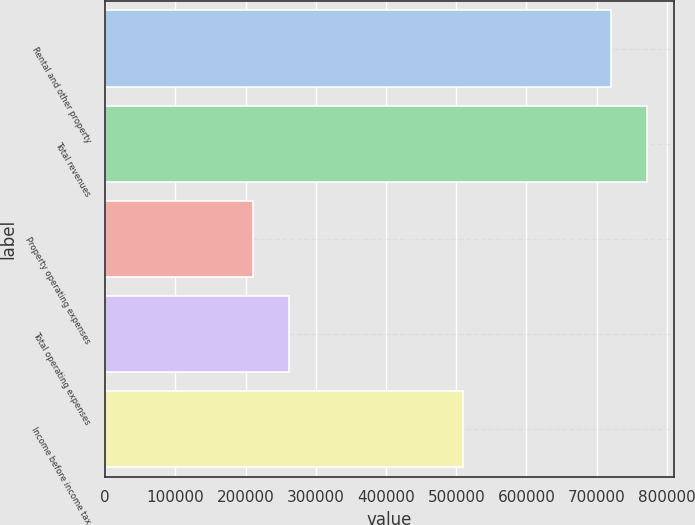Convert chart to OTSL. <chart><loc_0><loc_0><loc_500><loc_500><bar_chart><fcel>Rental and other property<fcel>Total revenues<fcel>Property operating expenses<fcel>Total operating expenses<fcel>Income before income tax<nl><fcel>720302<fcel>771290<fcel>210426<fcel>261414<fcel>509876<nl></chart> 